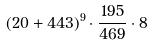<formula> <loc_0><loc_0><loc_500><loc_500>( 2 0 + 4 4 3 ) ^ { 9 } \cdot \frac { 1 9 5 } { 4 6 9 } \cdot 8</formula> 